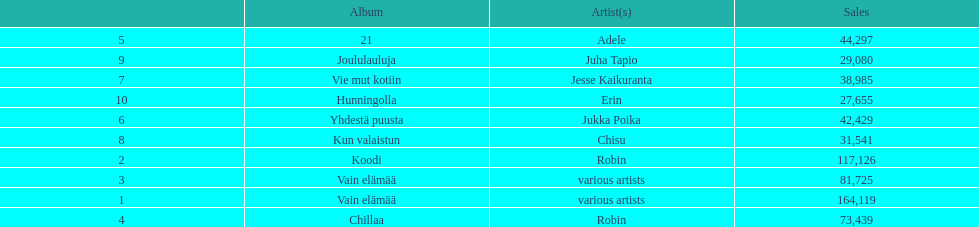Which were the number-one albums of 2012 in finland? Vain elämää, Koodi, Vain elämää, Chillaa, 21, Yhdestä puusta, Vie mut kotiin, Kun valaistun, Joululauluja, Hunningolla. Of those albums, which were by robin? Koodi, Chillaa. Of those albums by robin, which is not chillaa? Koodi. 